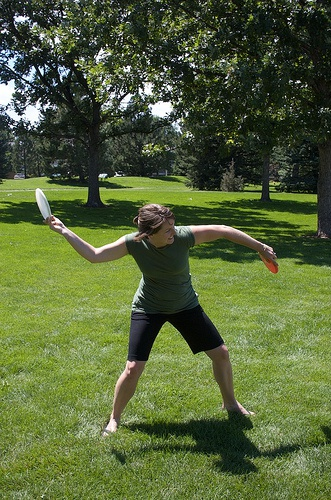Describe the objects in this image and their specific colors. I can see people in black, gray, and lightgray tones, frisbee in black, lightgray, and darkgray tones, and frisbee in black, brown, olive, and maroon tones in this image. 